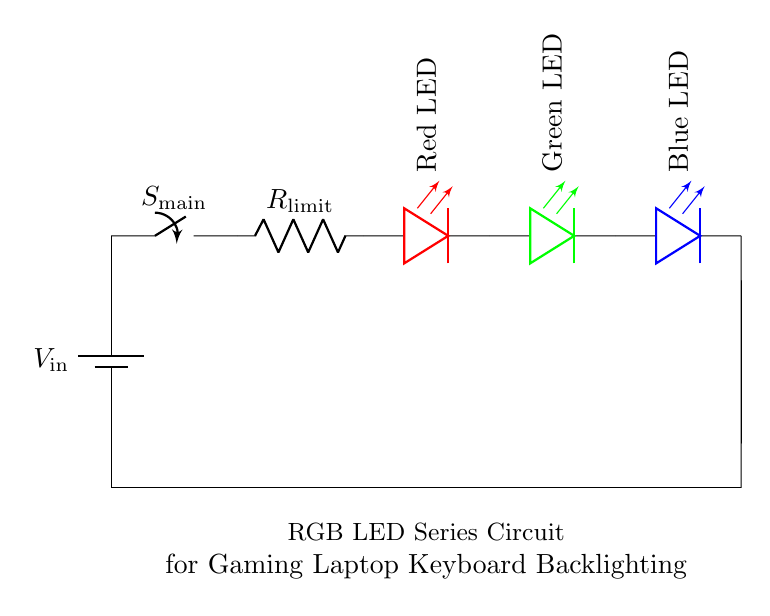What is the power source of the circuit? The power source is labeled as V_in in the circuit, which indicates it is a voltage supply.
Answer: V_in What component limits the current in the circuit? The component labeled R_limit is a resistor, and its purpose is to limit the current flowing through the LEDs.
Answer: R_limit What color is the LED placed first in the series? The first LED in the series is colored red, as indicated by the color labeling in the diagram.
Answer: Red LED How many LEDs are included in the circuit? The circuit contains three LEDs: one red, one green, and one blue. This is confirmed visually by counting the LED components in the diagram.
Answer: Three When the main switch is closed, how does the current flow through the circuit? The current flows from the battery, through the main switch, then through the current-limiting resistor, and subsequently through each LED in series before returning to ground. The series configuration ensures the same current flows through each component.
Answer: In series What happens if R_limit is too high? If R_limit is too high, it will reduce the current flowing through the LEDs too much, potentially causing them not to light up brightly or at all. This reasoning is based on Ohm’s Law, where higher resistance leads to lower current if voltage is constant.
Answer: LEDs may not light up 